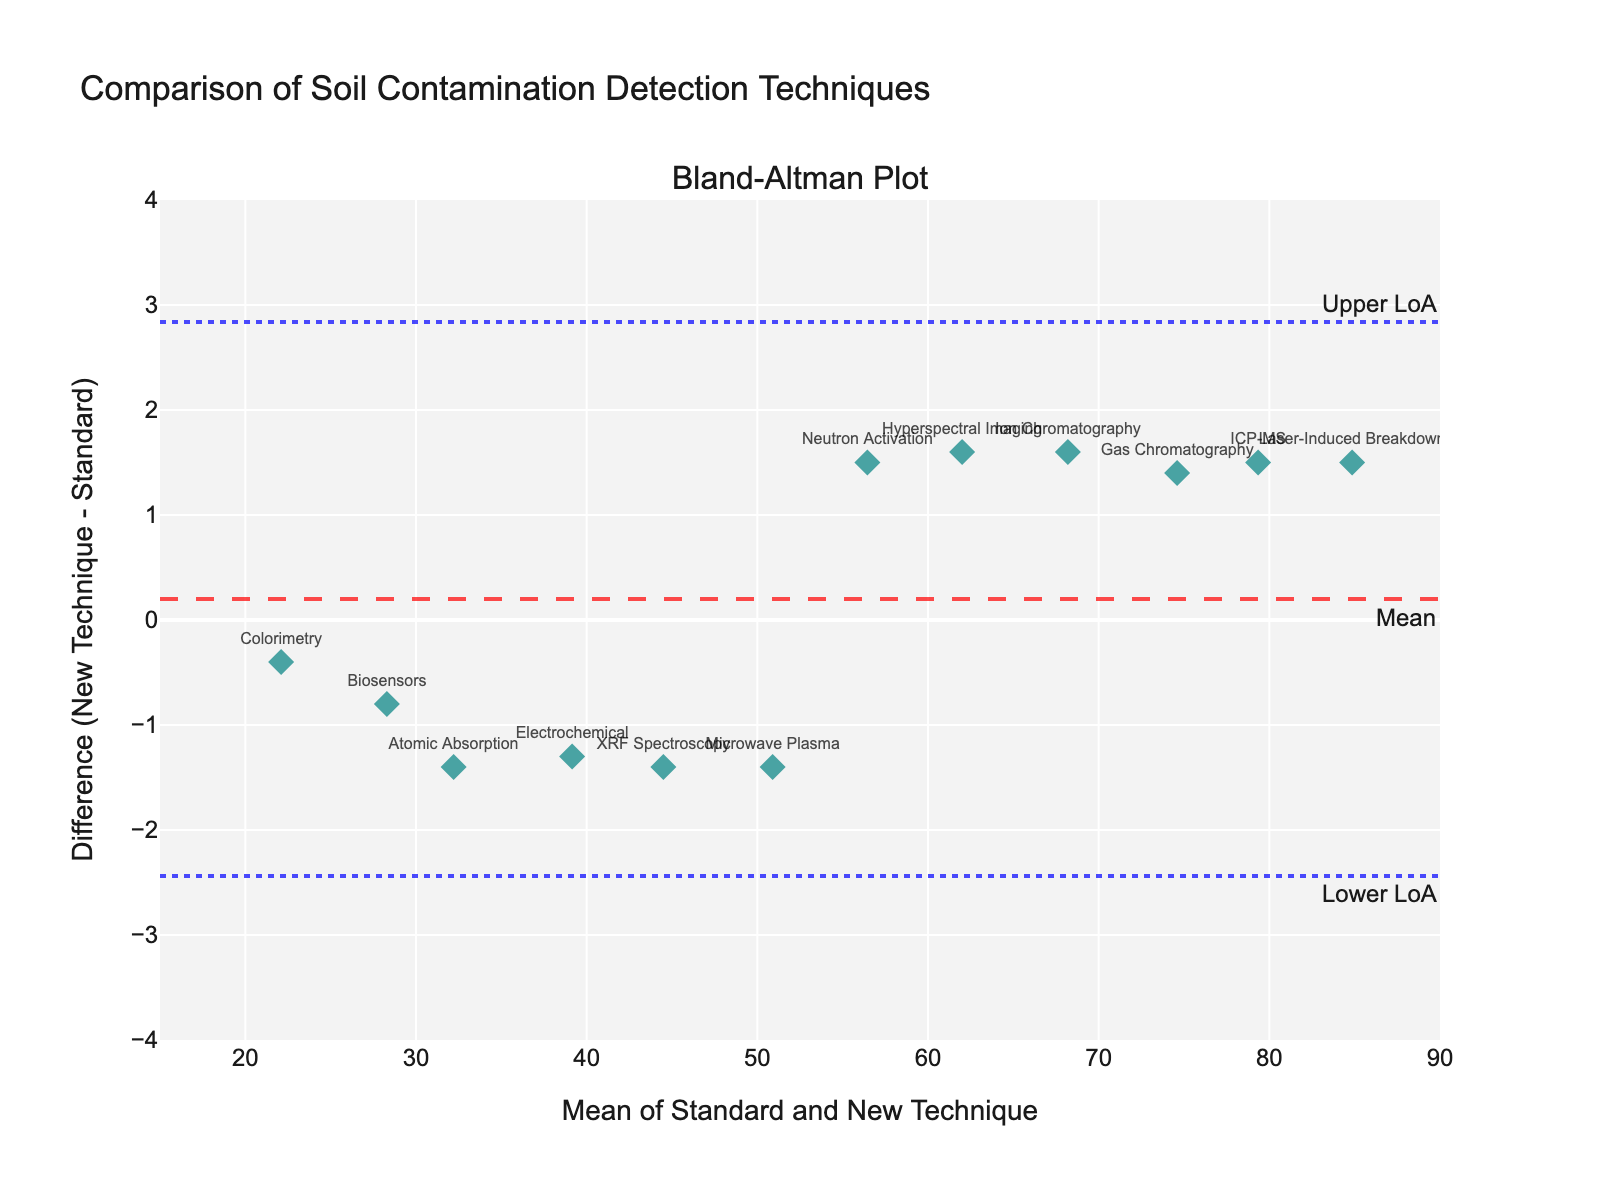What's the title of the plot? The title is usually displayed at the top of the plot. Here, it is written clearly as "Comparison of Soil Contamination Detection Techniques".
Answer: Comparison of Soil Contamination Detection Techniques What are the x-axis and y-axis labels? The x-axis label is found at the bottom and is "Mean of Standard and New Technique". The y-axis label is found on the left side and is "Difference (New Technique - Standard)".
Answer: Mean of Standard and New Technique, Difference (New Technique - Standard) How many techniques are compared in the plot? Each technique is represented by a marker in the plot. By counting the markers, we determine there are 12 techniques compared.
Answer: 12 What is the range for the x-axis? The x-axis range is displayed with minimum and maximum values. Here, it ranges from 15 to 90.
Answer: 15 to 90 What technique has the highest mean value? To find the highest mean value, locate the marker farthest to the right. The technique "Laser-Induced Breakdown" with a mean value around 84.85 has the highest.
Answer: Laser-Induced Breakdown What is the mean difference indicated in the plot? The mean difference is represented by a dashed horizontal line labeled "Mean". It appears at 0.58 on the y-axis.
Answer: 0.58 What are the upper and lower limits of agreement (LoA)? The upper and lower limits of agreement are indicated by two dotted horizontal lines labeled "Upper LoA" and "Lower LoA". These lines appear at approximately 3.40 and -2.24, respectively.
Answer: 3.40 and -2.24 What is the difference for the "Gas Chromatography" technique? Find the marker labeled "Gas Chromatography" and see where it intersects the y-axis. It shows a difference of approximately 1.4.
Answer: 1.4 Which technique shows the largest positive difference? The largest positive difference is the point highest above the x-axis, indicating "Neutron Activation" with a difference around 1.5.
Answer: Neutron Activation Is there any technique that shows a negative difference? Look for markers below the x-axis, indicating negative differences. Techniques like "XRF Spectroscopy" and "Electrochemical" show negative differences.
Answer: Yes 